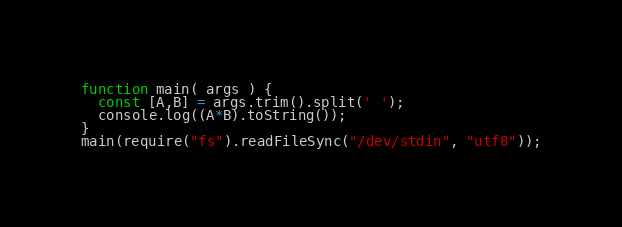<code> <loc_0><loc_0><loc_500><loc_500><_JavaScript_>function main( args ) {
  const [A,B] = args.trim().split(' ');
  console.log((A*B).toString());
}
main(require("fs").readFileSync("/dev/stdin", "utf8"));</code> 